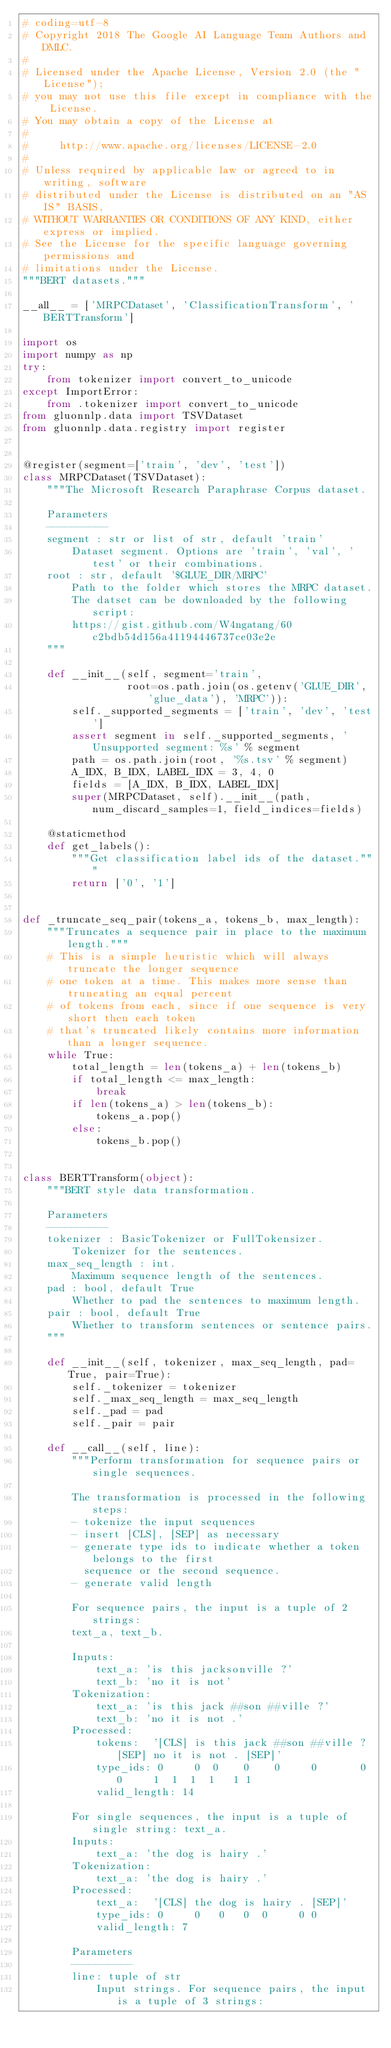Convert code to text. <code><loc_0><loc_0><loc_500><loc_500><_Python_># coding=utf-8
# Copyright 2018 The Google AI Language Team Authors and DMLC.
#
# Licensed under the Apache License, Version 2.0 (the "License");
# you may not use this file except in compliance with the License.
# You may obtain a copy of the License at
#
#     http://www.apache.org/licenses/LICENSE-2.0
#
# Unless required by applicable law or agreed to in writing, software
# distributed under the License is distributed on an "AS IS" BASIS,
# WITHOUT WARRANTIES OR CONDITIONS OF ANY KIND, either express or implied.
# See the License for the specific language governing permissions and
# limitations under the License.
"""BERT datasets."""

__all__ = ['MRPCDataset', 'ClassificationTransform', 'BERTTransform']

import os
import numpy as np
try:
    from tokenizer import convert_to_unicode
except ImportError:
    from .tokenizer import convert_to_unicode
from gluonnlp.data import TSVDataset
from gluonnlp.data.registry import register


@register(segment=['train', 'dev', 'test'])
class MRPCDataset(TSVDataset):
    """The Microsoft Research Paraphrase Corpus dataset.

    Parameters
    ----------
    segment : str or list of str, default 'train'
        Dataset segment. Options are 'train', 'val', 'test' or their combinations.
    root : str, default '$GLUE_DIR/MRPC'
        Path to the folder which stores the MRPC dataset.
        The datset can be downloaded by the following script:
        https://gist.github.com/W4ngatang/60c2bdb54d156a41194446737ce03e2e
    """

    def __init__(self, segment='train',
                 root=os.path.join(os.getenv('GLUE_DIR', 'glue_data'), 'MRPC')):
        self._supported_segments = ['train', 'dev', 'test']
        assert segment in self._supported_segments, 'Unsupported segment: %s' % segment
        path = os.path.join(root, '%s.tsv' % segment)
        A_IDX, B_IDX, LABEL_IDX = 3, 4, 0
        fields = [A_IDX, B_IDX, LABEL_IDX]
        super(MRPCDataset, self).__init__(path, num_discard_samples=1, field_indices=fields)

    @staticmethod
    def get_labels():
        """Get classification label ids of the dataset."""
        return ['0', '1']


def _truncate_seq_pair(tokens_a, tokens_b, max_length):
    """Truncates a sequence pair in place to the maximum length."""
    # This is a simple heuristic which will always truncate the longer sequence
    # one token at a time. This makes more sense than truncating an equal percent
    # of tokens from each, since if one sequence is very short then each token
    # that's truncated likely contains more information than a longer sequence.
    while True:
        total_length = len(tokens_a) + len(tokens_b)
        if total_length <= max_length:
            break
        if len(tokens_a) > len(tokens_b):
            tokens_a.pop()
        else:
            tokens_b.pop()


class BERTTransform(object):
    """BERT style data transformation.

    Parameters
    ----------
    tokenizer : BasicTokenizer or FullTokensizer.
        Tokenizer for the sentences.
    max_seq_length : int.
        Maximum sequence length of the sentences.
    pad : bool, default True
        Whether to pad the sentences to maximum length.
    pair : bool, default True
        Whether to transform sentences or sentence pairs.
    """

    def __init__(self, tokenizer, max_seq_length, pad=True, pair=True):
        self._tokenizer = tokenizer
        self._max_seq_length = max_seq_length
        self._pad = pad
        self._pair = pair

    def __call__(self, line):
        """Perform transformation for sequence pairs or single sequences.

        The transformation is processed in the following steps:
        - tokenize the input sequences
        - insert [CLS], [SEP] as necessary
        - generate type ids to indicate whether a token belongs to the first
          sequence or the second sequence.
        - generate valid length

        For sequence pairs, the input is a tuple of 2 strings:
        text_a, text_b.

        Inputs:
            text_a: 'is this jacksonville ?'
            text_b: 'no it is not'
        Tokenization:
            text_a: 'is this jack ##son ##ville ?'
            text_b: 'no it is not .'
        Processed:
            tokens:  '[CLS] is this jack ##son ##ville ? [SEP] no it is not . [SEP]'
            type_ids: 0     0  0    0    0     0       0 0     1  1  1  1   1 1
            valid_length: 14

        For single sequences, the input is a tuple of single string: text_a.
        Inputs:
            text_a: 'the dog is hairy .'
        Tokenization:
            text_a: 'the dog is hairy .'
        Processed:
            text_a:  '[CLS] the dog is hairy . [SEP]'
            type_ids: 0     0   0   0  0     0 0
            valid_length: 7

        Parameters
        ----------
        line: tuple of str
            Input strings. For sequence pairs, the input is a tuple of 3 strings:</code> 